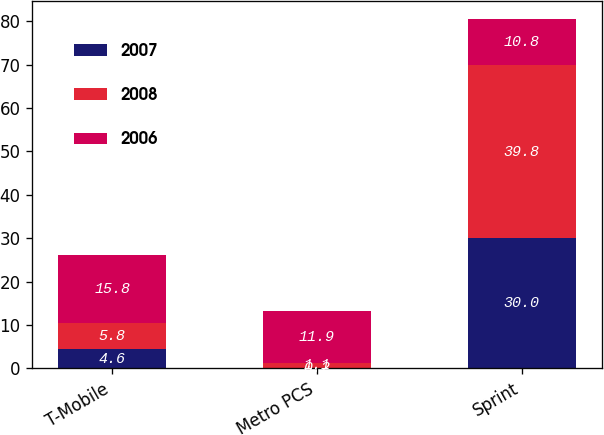Convert chart. <chart><loc_0><loc_0><loc_500><loc_500><stacked_bar_chart><ecel><fcel>T-Mobile<fcel>Metro PCS<fcel>Sprint<nl><fcel>2007<fcel>4.6<fcel>0.2<fcel>30<nl><fcel>2008<fcel>5.8<fcel>1.1<fcel>39.8<nl><fcel>2006<fcel>15.8<fcel>11.9<fcel>10.8<nl></chart> 